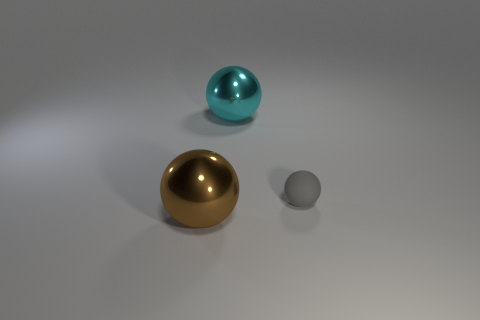Add 3 gray rubber balls. How many objects exist? 6 Subtract 1 cyan spheres. How many objects are left? 2 Subtract all shiny blocks. Subtract all small gray objects. How many objects are left? 2 Add 1 large spheres. How many large spheres are left? 3 Add 1 big blue matte cubes. How many big blue matte cubes exist? 1 